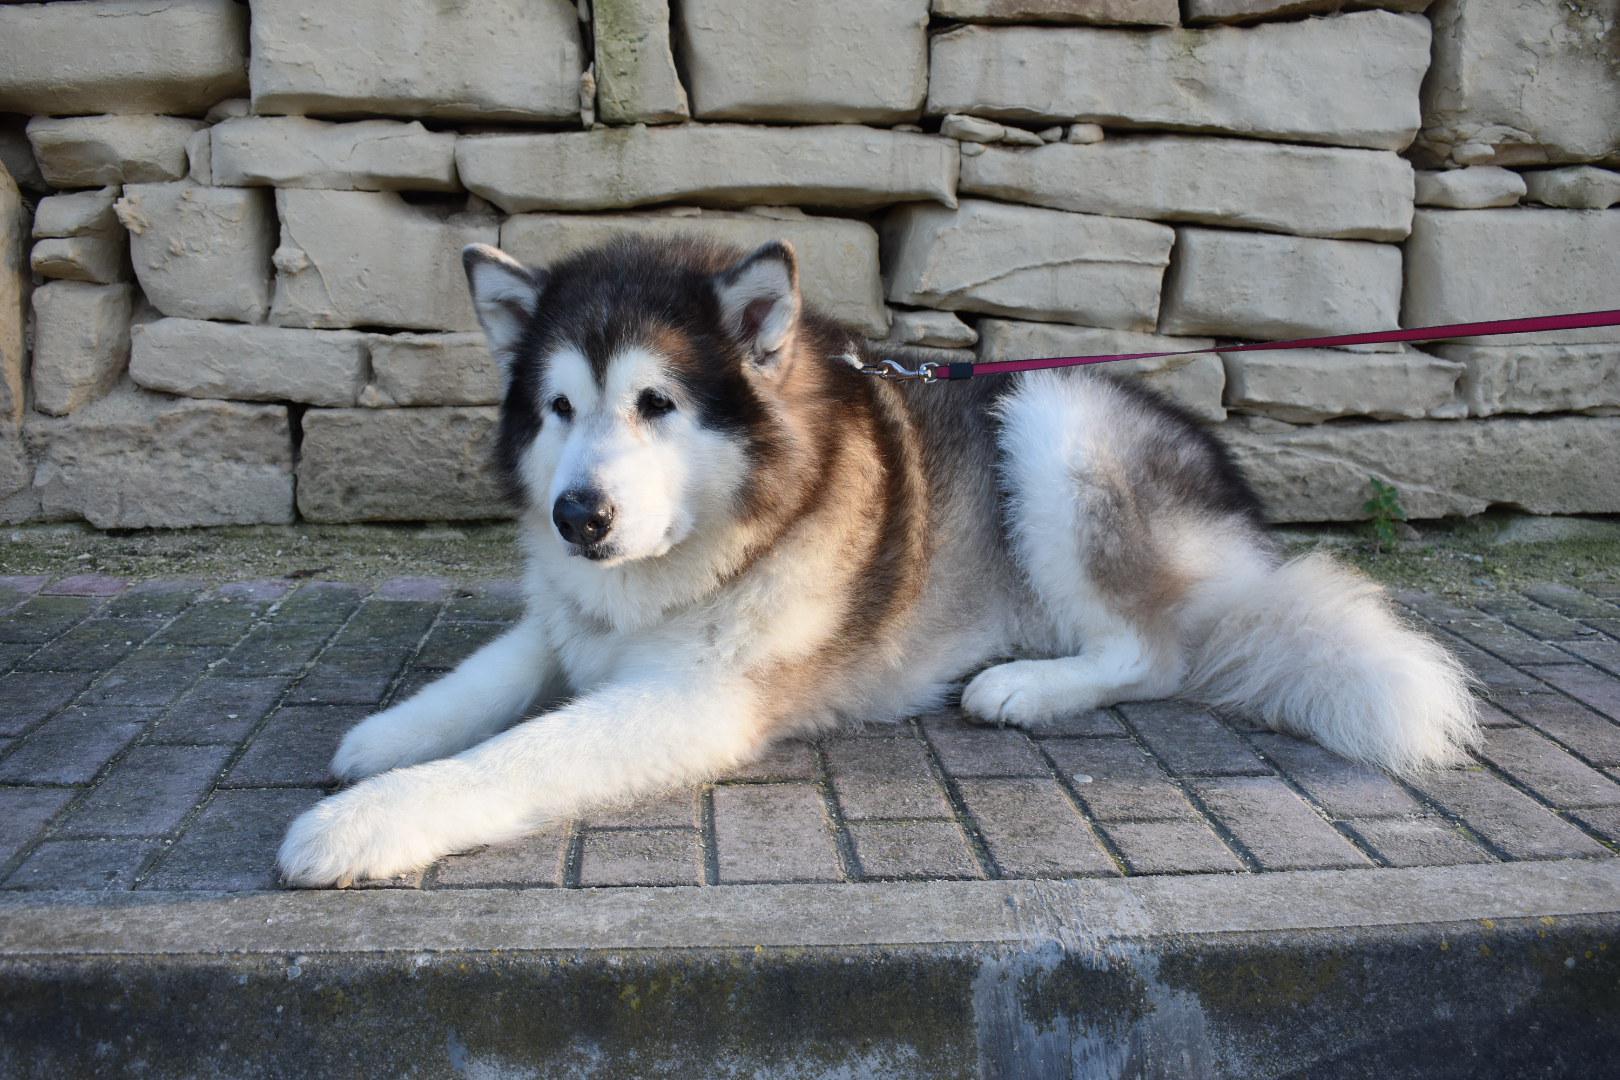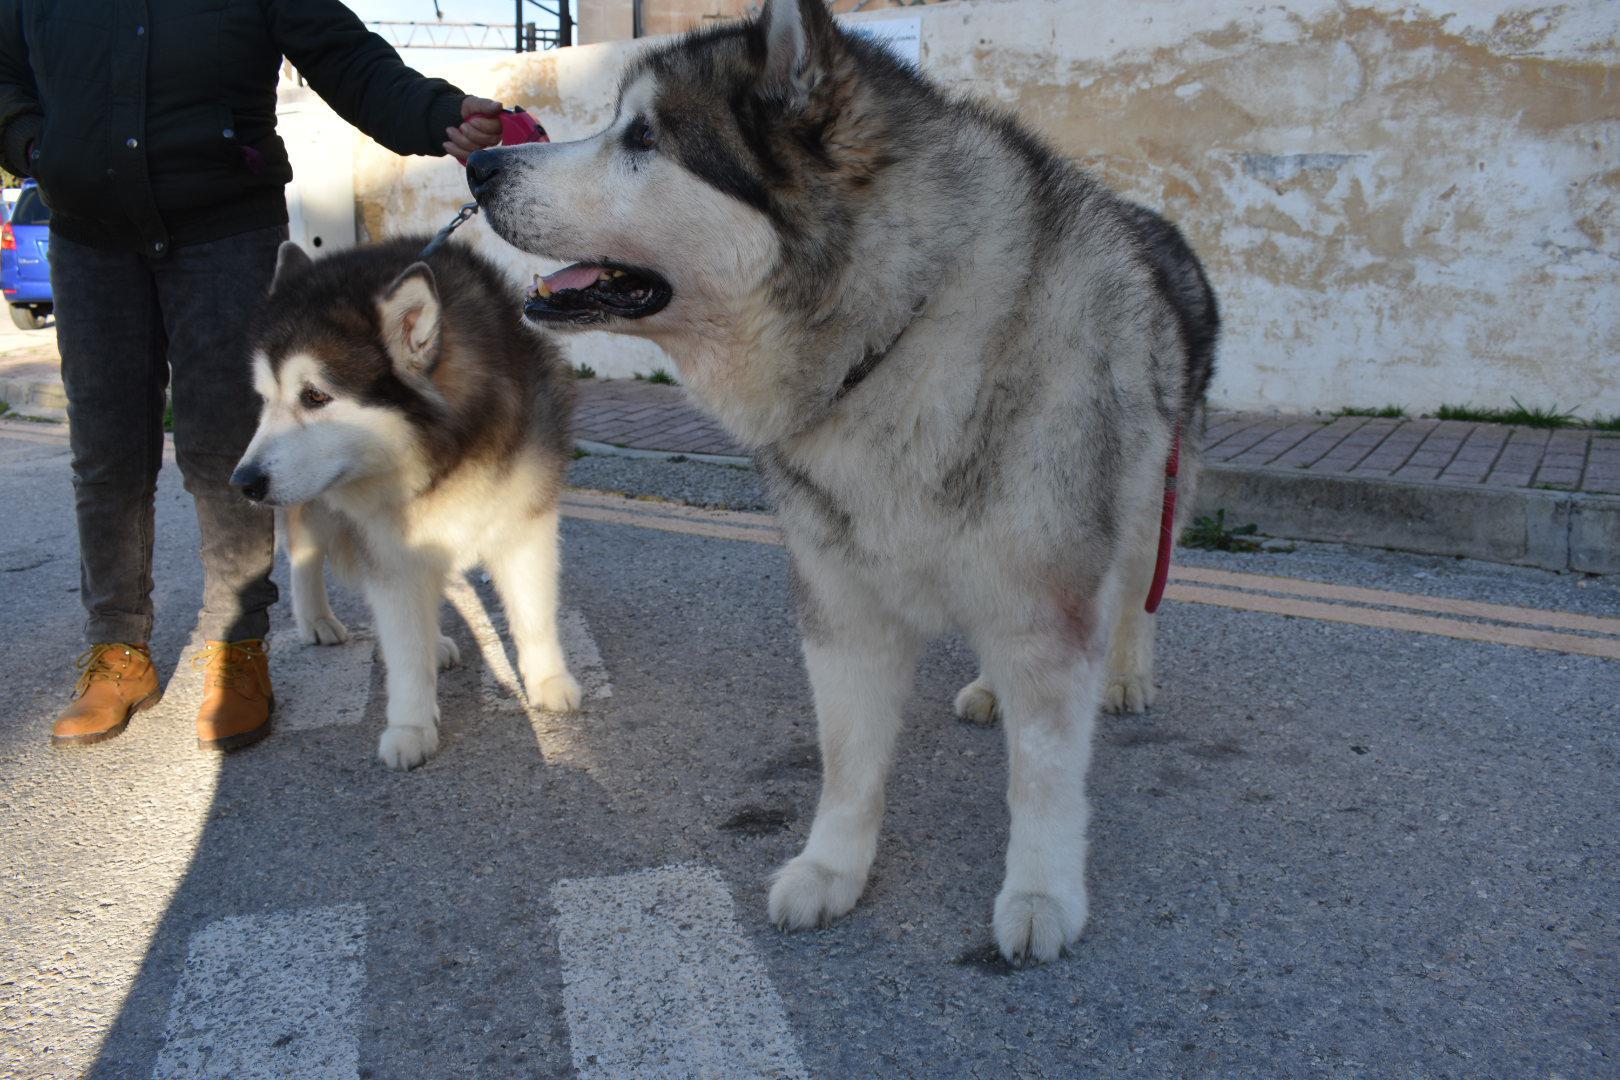The first image is the image on the left, the second image is the image on the right. Assess this claim about the two images: "In the image to the right, a human stands near the dogs.". Correct or not? Answer yes or no. Yes. The first image is the image on the left, the second image is the image on the right. Assess this claim about the two images: "The left image features one standing open-mouthed dog, and the right image features one standing close-mouthed dog.". Correct or not? Answer yes or no. No. 